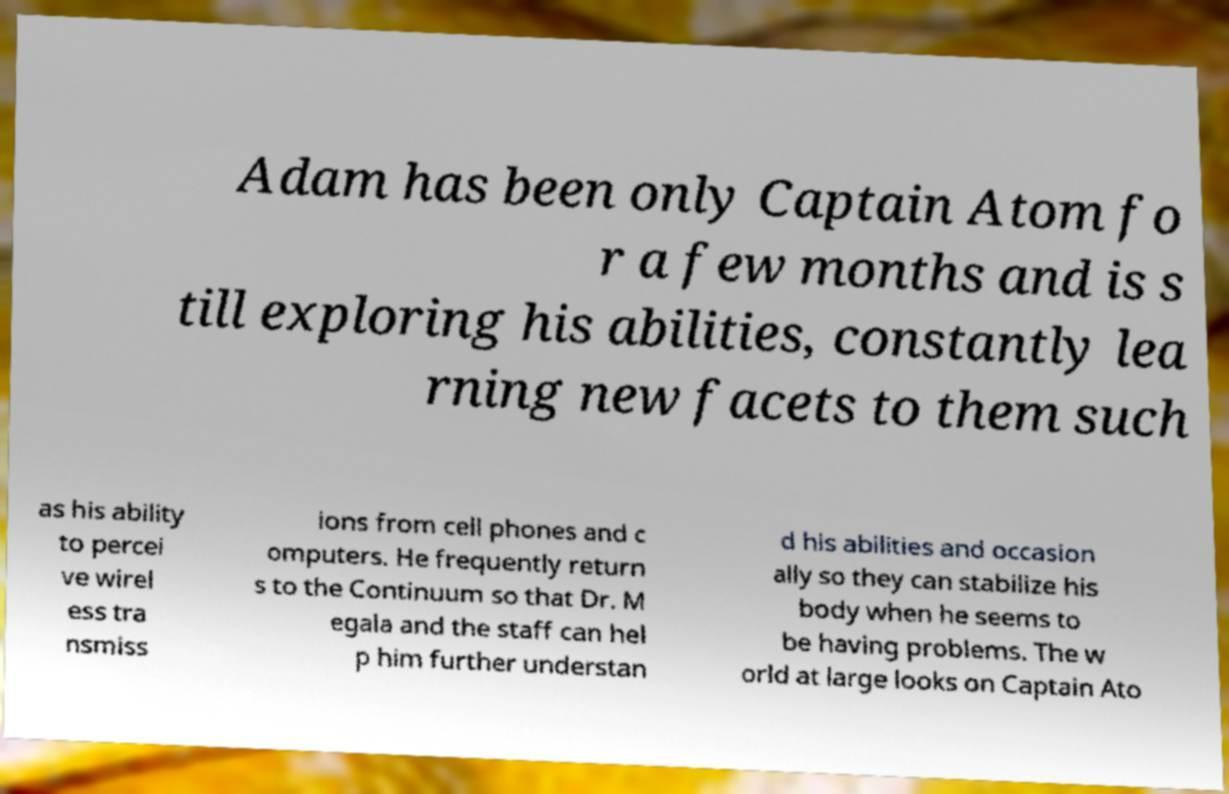Can you read and provide the text displayed in the image?This photo seems to have some interesting text. Can you extract and type it out for me? Adam has been only Captain Atom fo r a few months and is s till exploring his abilities, constantly lea rning new facets to them such as his ability to percei ve wirel ess tra nsmiss ions from cell phones and c omputers. He frequently return s to the Continuum so that Dr. M egala and the staff can hel p him further understan d his abilities and occasion ally so they can stabilize his body when he seems to be having problems. The w orld at large looks on Captain Ato 